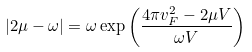<formula> <loc_0><loc_0><loc_500><loc_500>| 2 \mu - \omega | = \omega \exp \left ( \frac { 4 \pi v _ { F } ^ { 2 } - 2 \mu V } { \omega V } \right )</formula> 